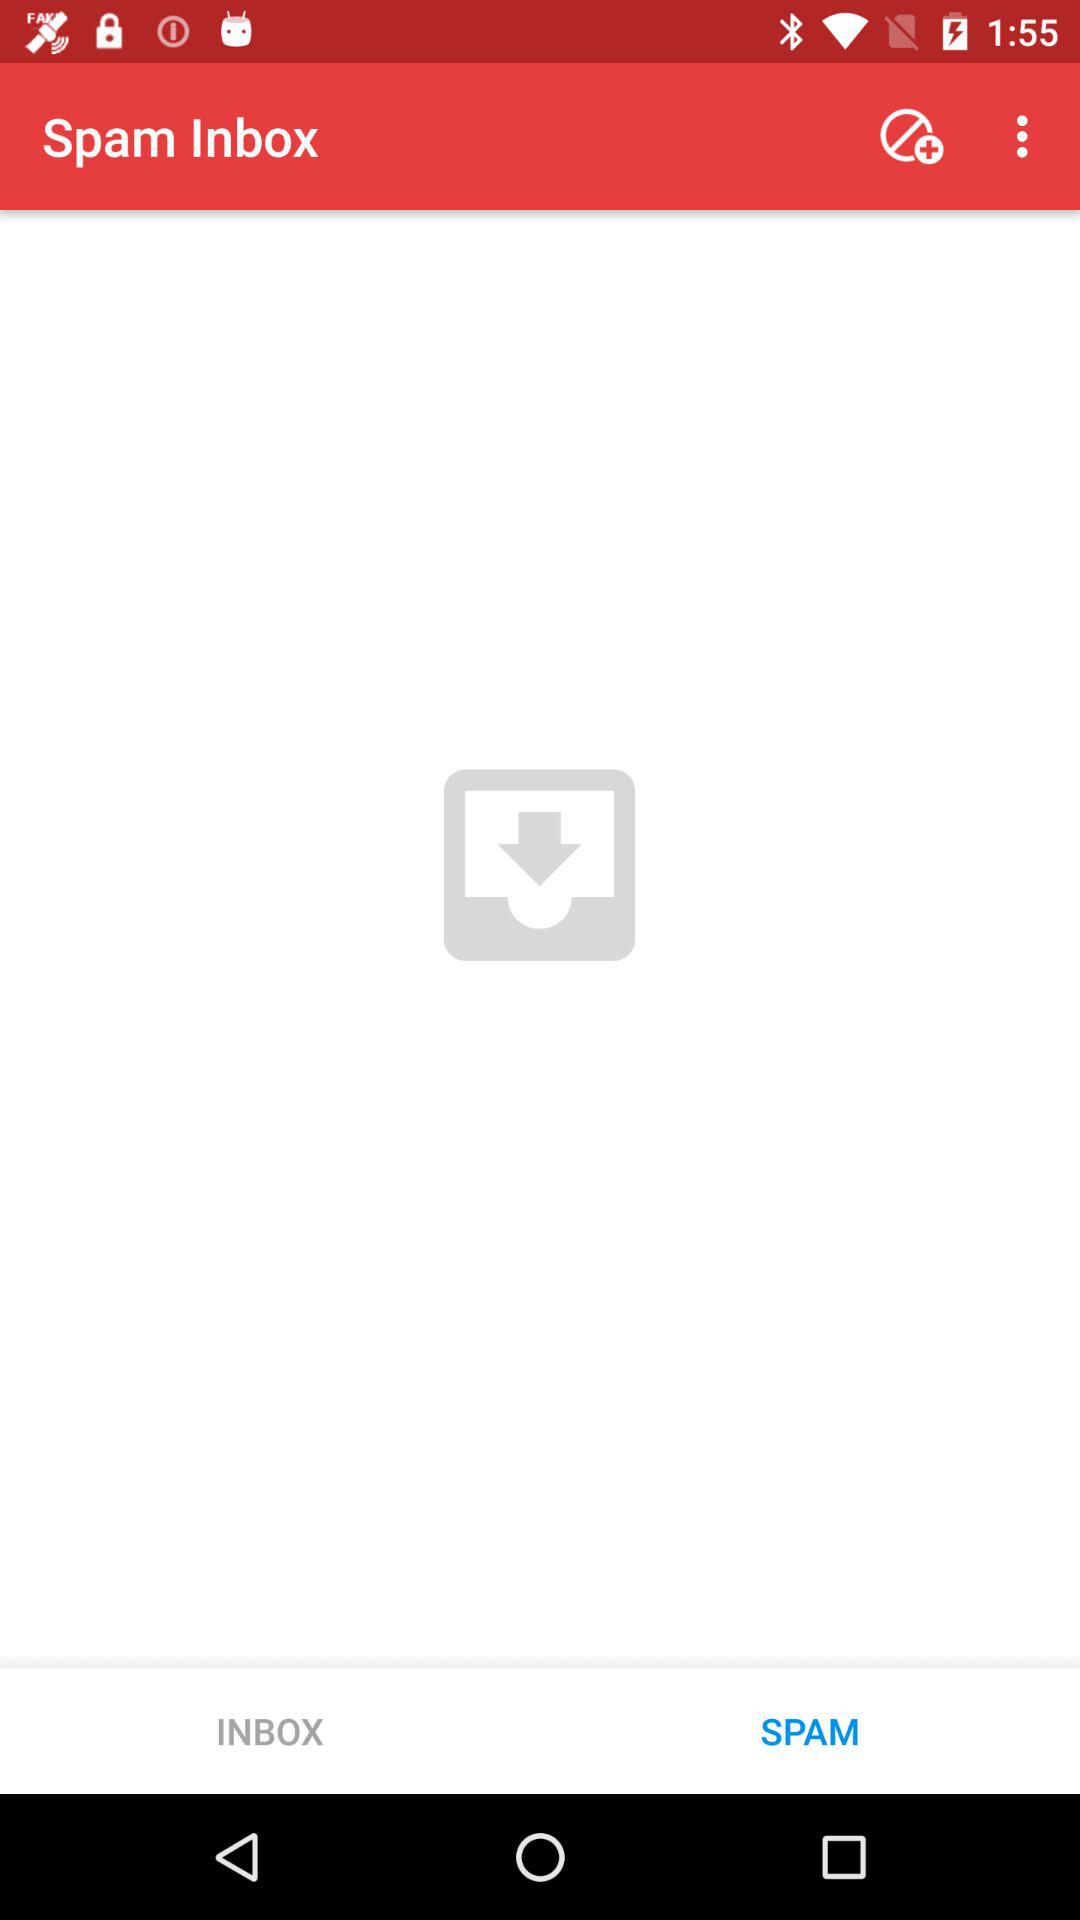Which tab is selected? The selected tab is "SPAM". 